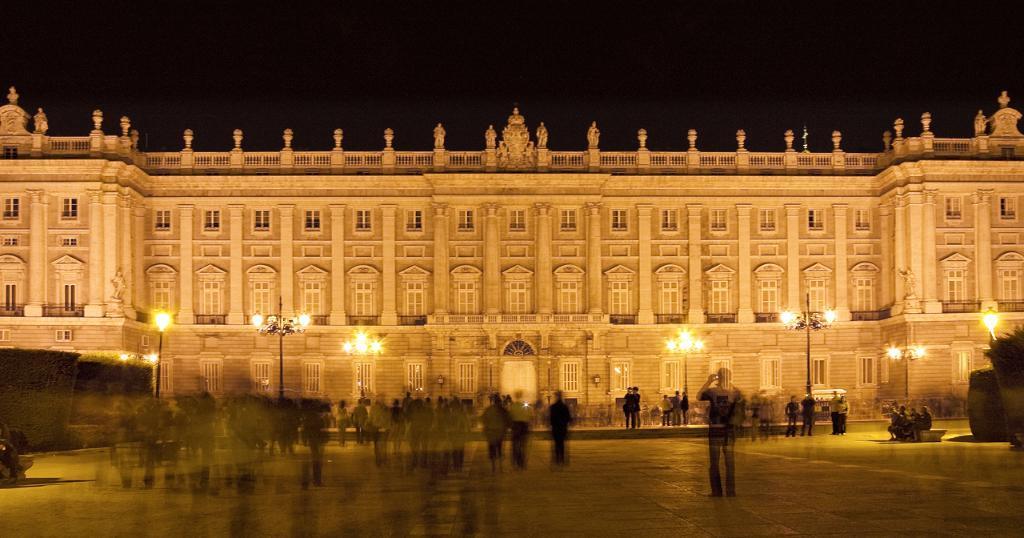In one or two sentences, can you explain what this image depicts? In the center of the image there is a palace. At the bottom there are people and we can see poles. There are lights. In the background there is sky. 